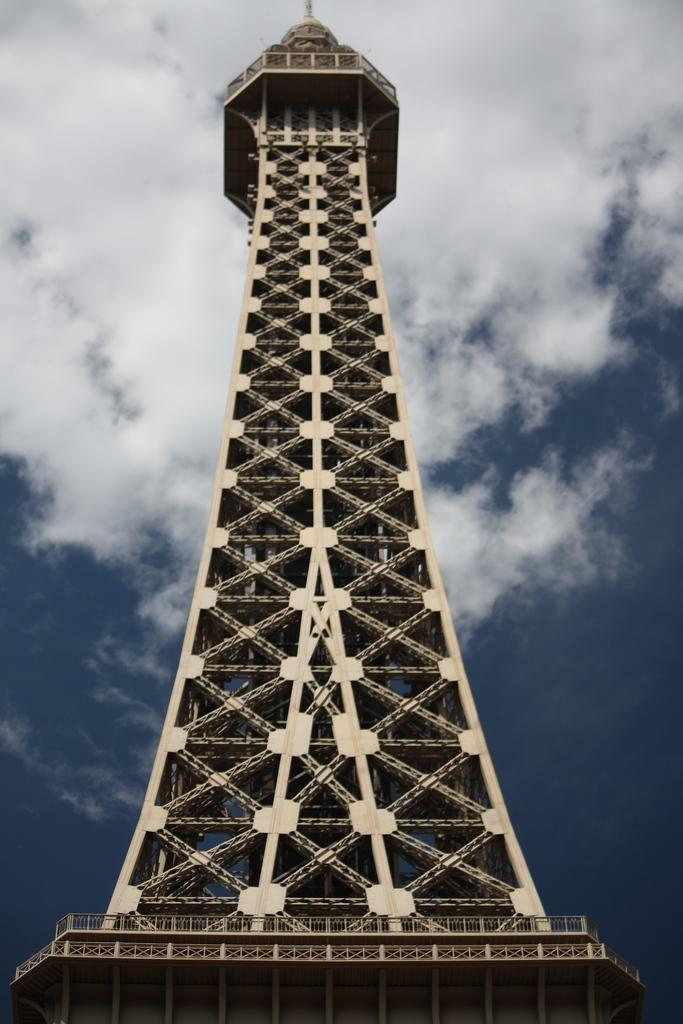What famous landmark can be seen in the image? The Eiffel Tower is visible in the image. What type of natural elements can be seen in the background of the image? There are clouds in the background of the image. What else is visible in the background of the image? The sky is visible in the background of the image. How many cans are stacked on top of the Eiffel Tower in the image? There are no cans present in the image; it only features the Eiffel Tower and the background elements. 